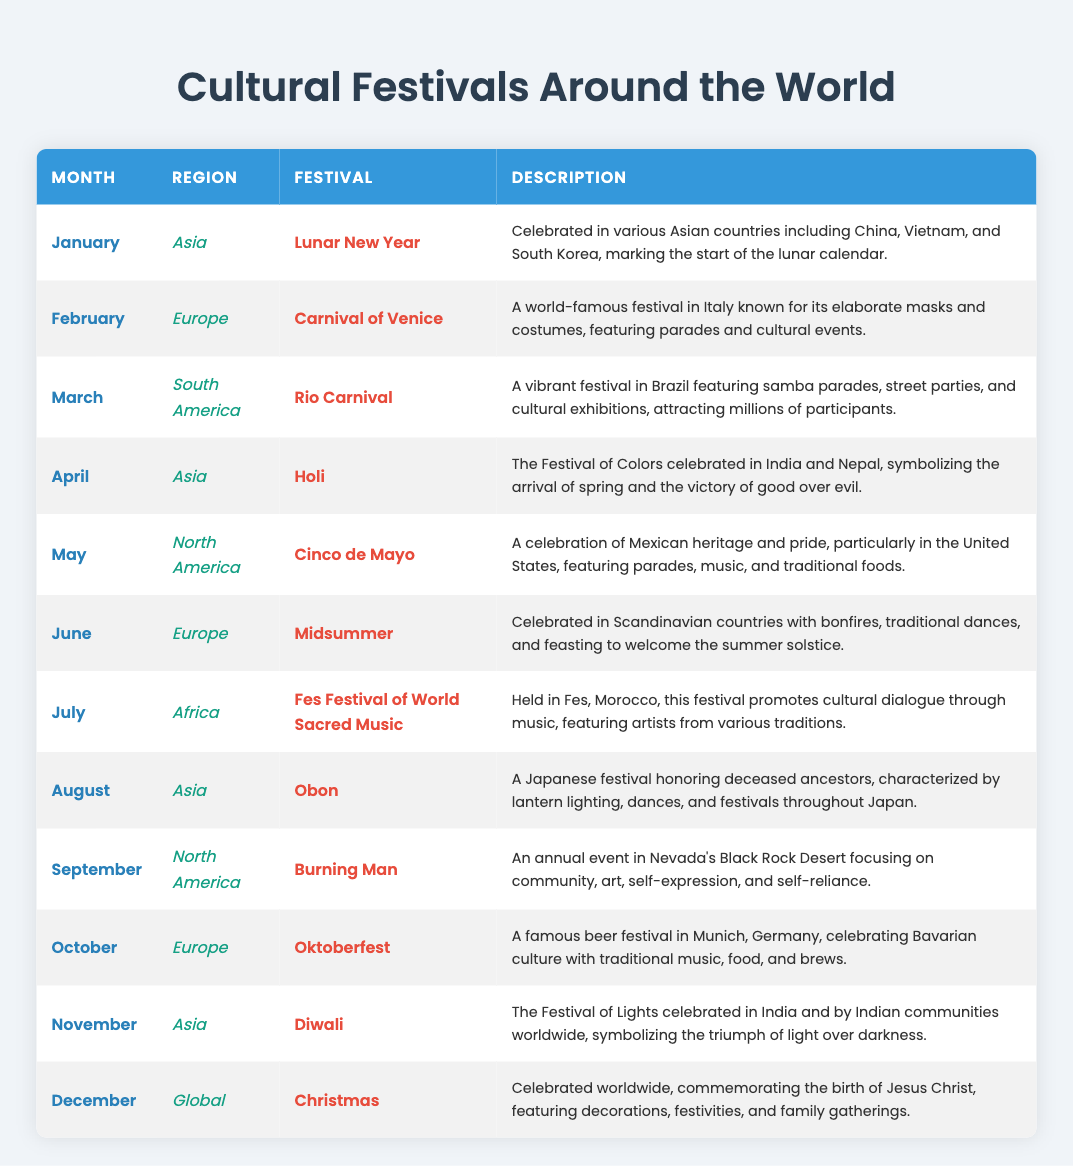What is the festival celebrated in December? According to the table, the festival listed for December is Christmas.
Answer: Christmas In which month is Diwali celebrated? The table indicates that Diwali is celebrated in November.
Answer: November How many festivals are celebrated in Asia? By counting all the festivals listed under the Asia region in the table, we find there are four: Lunar New Year, Holi, Obon, and Diwali.
Answer: Four Is the Rio Carnival celebrated in Europe? The table lists the Rio Carnival under South America, hence it is not celebrated in Europe.
Answer: No Which festival involves elaborate masks and costumes? The table specifies that the Carnival of Venice, celebrated in February in Europe, is known for its elaborate masks and costumes.
Answer: Carnival of Venice What is the average number of festivals celebrated per month? There are twelve festivals listed in the table across twelve months, so the average number of festivals celebrated per month is 12/12 = 1.
Answer: 1 What region hosts the Burning Man festival? The table clearly designates Burning Man as happening in North America during September.
Answer: North America How many months feature festivals that honor deceased ancestors? The table indicates two festivals that honor deceased ancestors, which are Obon in August and one can argue that Diwali in November also symbolizes remembrance in some interpretations. However, strictly for ancestor honoring, only Obon clearly states this.
Answer: One 